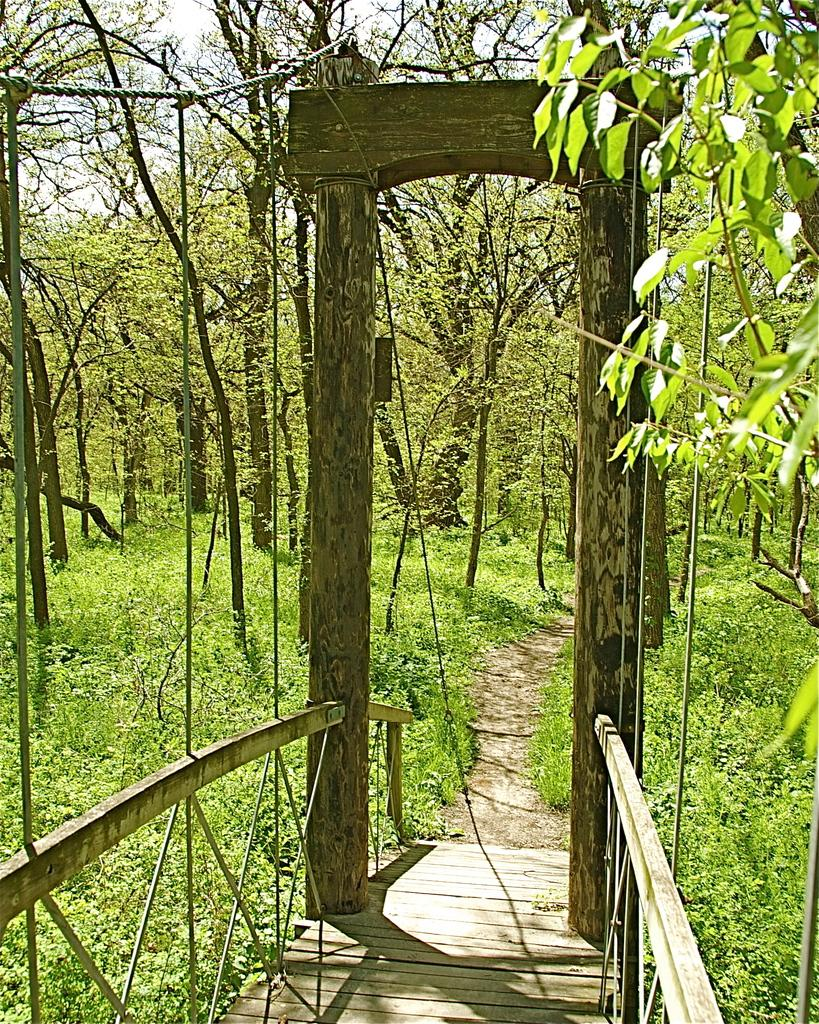What type of vegetation can be seen in the background of the image? There are plants and trees in the background of the image. What structure is present in the image? There is a wooden bridge in the image. Can you tell me how many horses are standing on the wooden bridge in the image? There are no horses present in the image; it only features plants, trees, and a wooden bridge. What type of material is the wax used for in the image? There is no wax present in the image. 